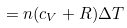<formula> <loc_0><loc_0><loc_500><loc_500>= n ( c _ { V } + R ) \Delta T</formula> 